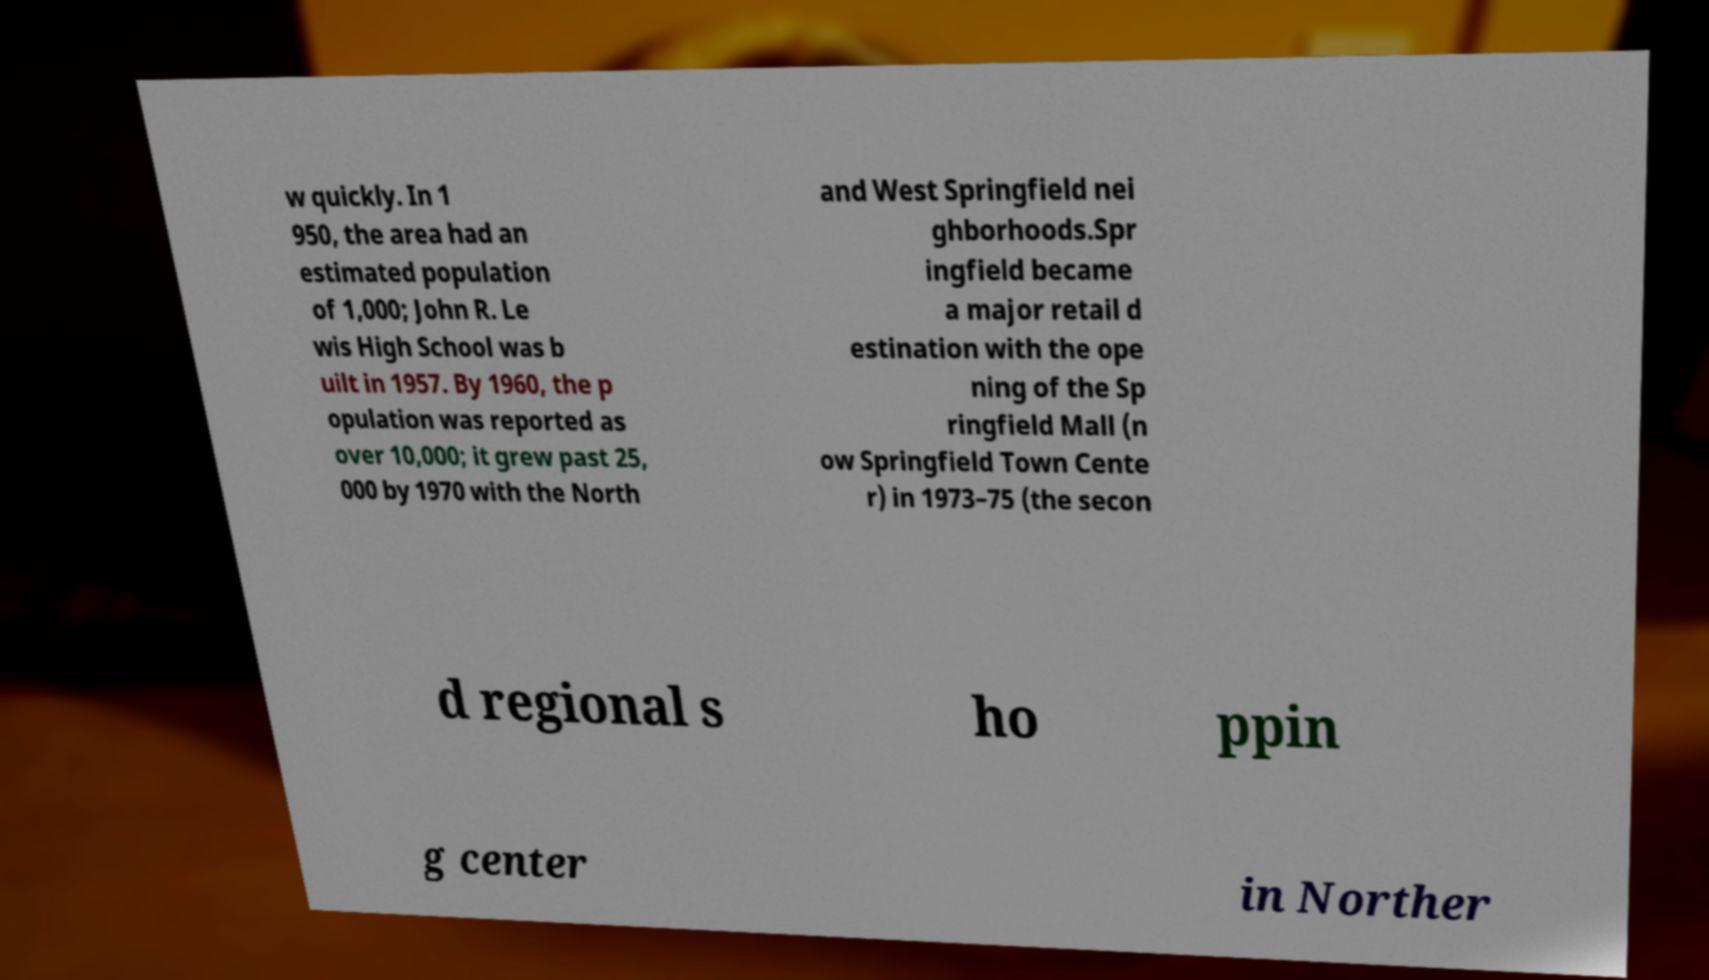Can you read and provide the text displayed in the image?This photo seems to have some interesting text. Can you extract and type it out for me? w quickly. In 1 950, the area had an estimated population of 1,000; John R. Le wis High School was b uilt in 1957. By 1960, the p opulation was reported as over 10,000; it grew past 25, 000 by 1970 with the North and West Springfield nei ghborhoods.Spr ingfield became a major retail d estination with the ope ning of the Sp ringfield Mall (n ow Springfield Town Cente r) in 1973–75 (the secon d regional s ho ppin g center in Norther 